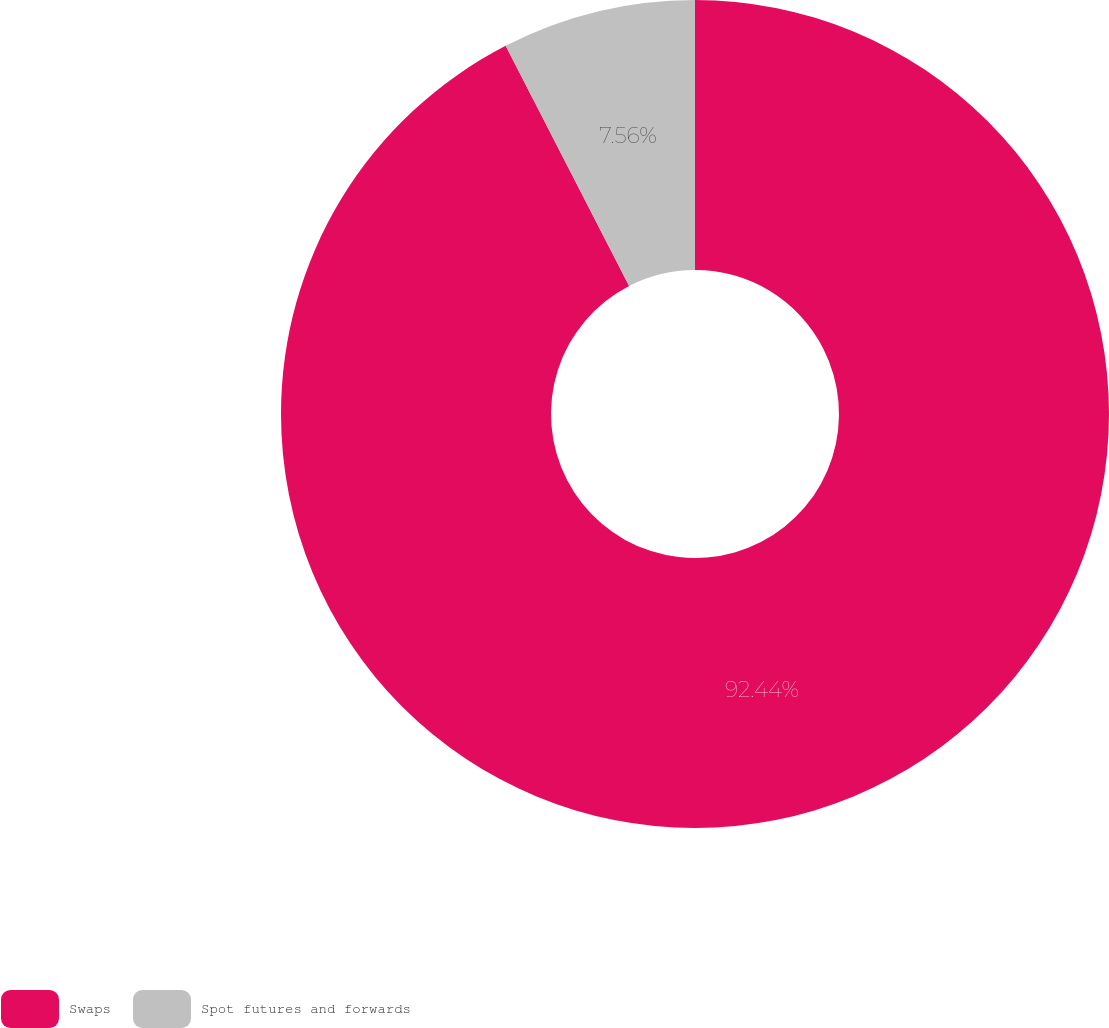<chart> <loc_0><loc_0><loc_500><loc_500><pie_chart><fcel>Swaps<fcel>Spot futures and forwards<nl><fcel>92.44%<fcel>7.56%<nl></chart> 